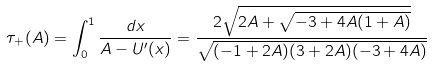<formula> <loc_0><loc_0><loc_500><loc_500>\tau _ { + } ( A ) = \int _ { 0 } ^ { 1 } \frac { d x } { A - U ^ { \prime } ( x ) } = \frac { 2 \sqrt { 2 A + \sqrt { - 3 + 4 A ( 1 + A ) } } } { \sqrt { ( - 1 + 2 A ) ( 3 + 2 A ) ( - 3 + 4 A ) } }</formula> 